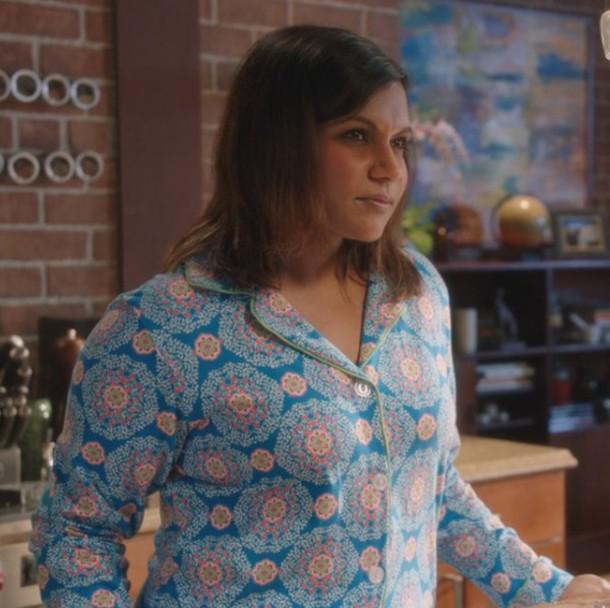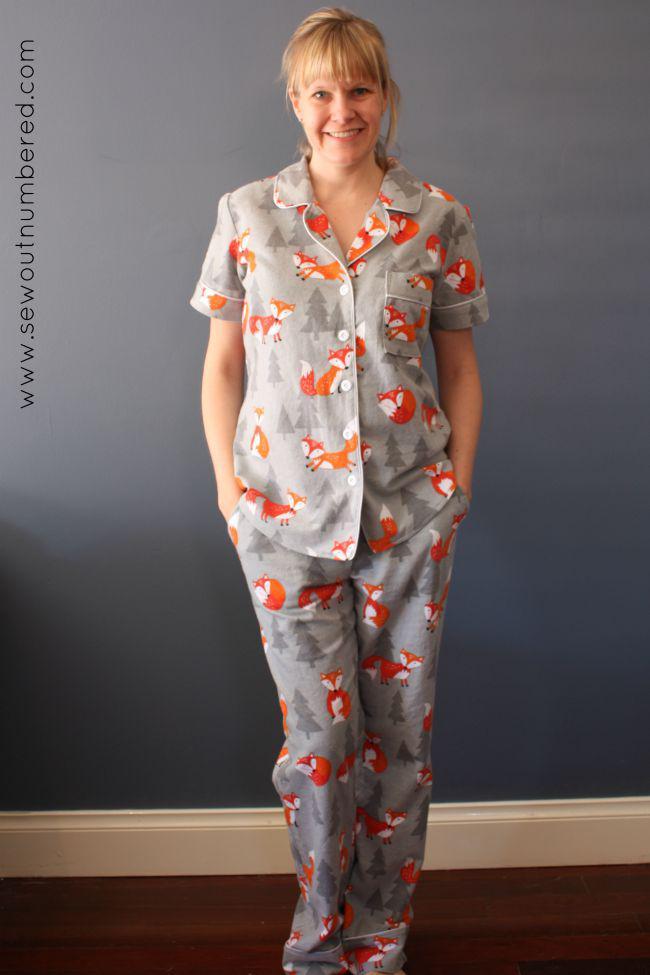The first image is the image on the left, the second image is the image on the right. Analyze the images presented: Is the assertion "A woman is wearing pajamas with small flowers on a dark purple background." valid? Answer yes or no. No. The first image is the image on the left, the second image is the image on the right. Analyze the images presented: Is the assertion "The woman in one of the image is wearing a pair of glasses." valid? Answer yes or no. No. 